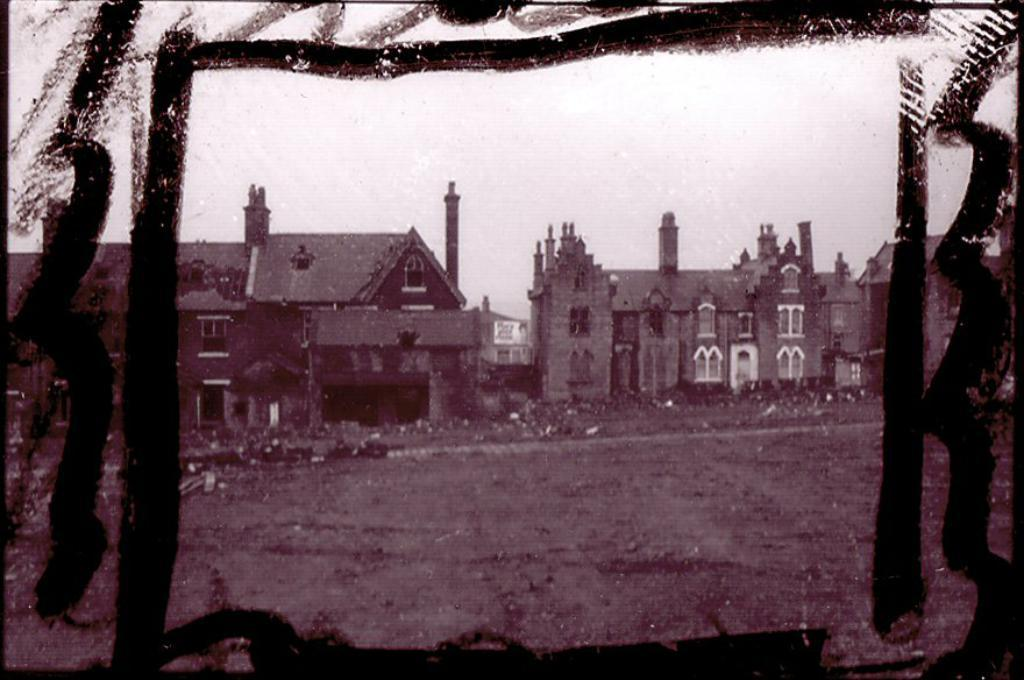What type of image is present in the picture? There is an old photograph in the image. What is shown in the old photograph? The photograph depicts a brown color castle house. What can be seen beneath the castle house in the image? There is a ground visible in the image. What type of sock is hanging on the castle house in the image? There is no sock present in the image; it only shows an old photograph of a brown color castle house. 